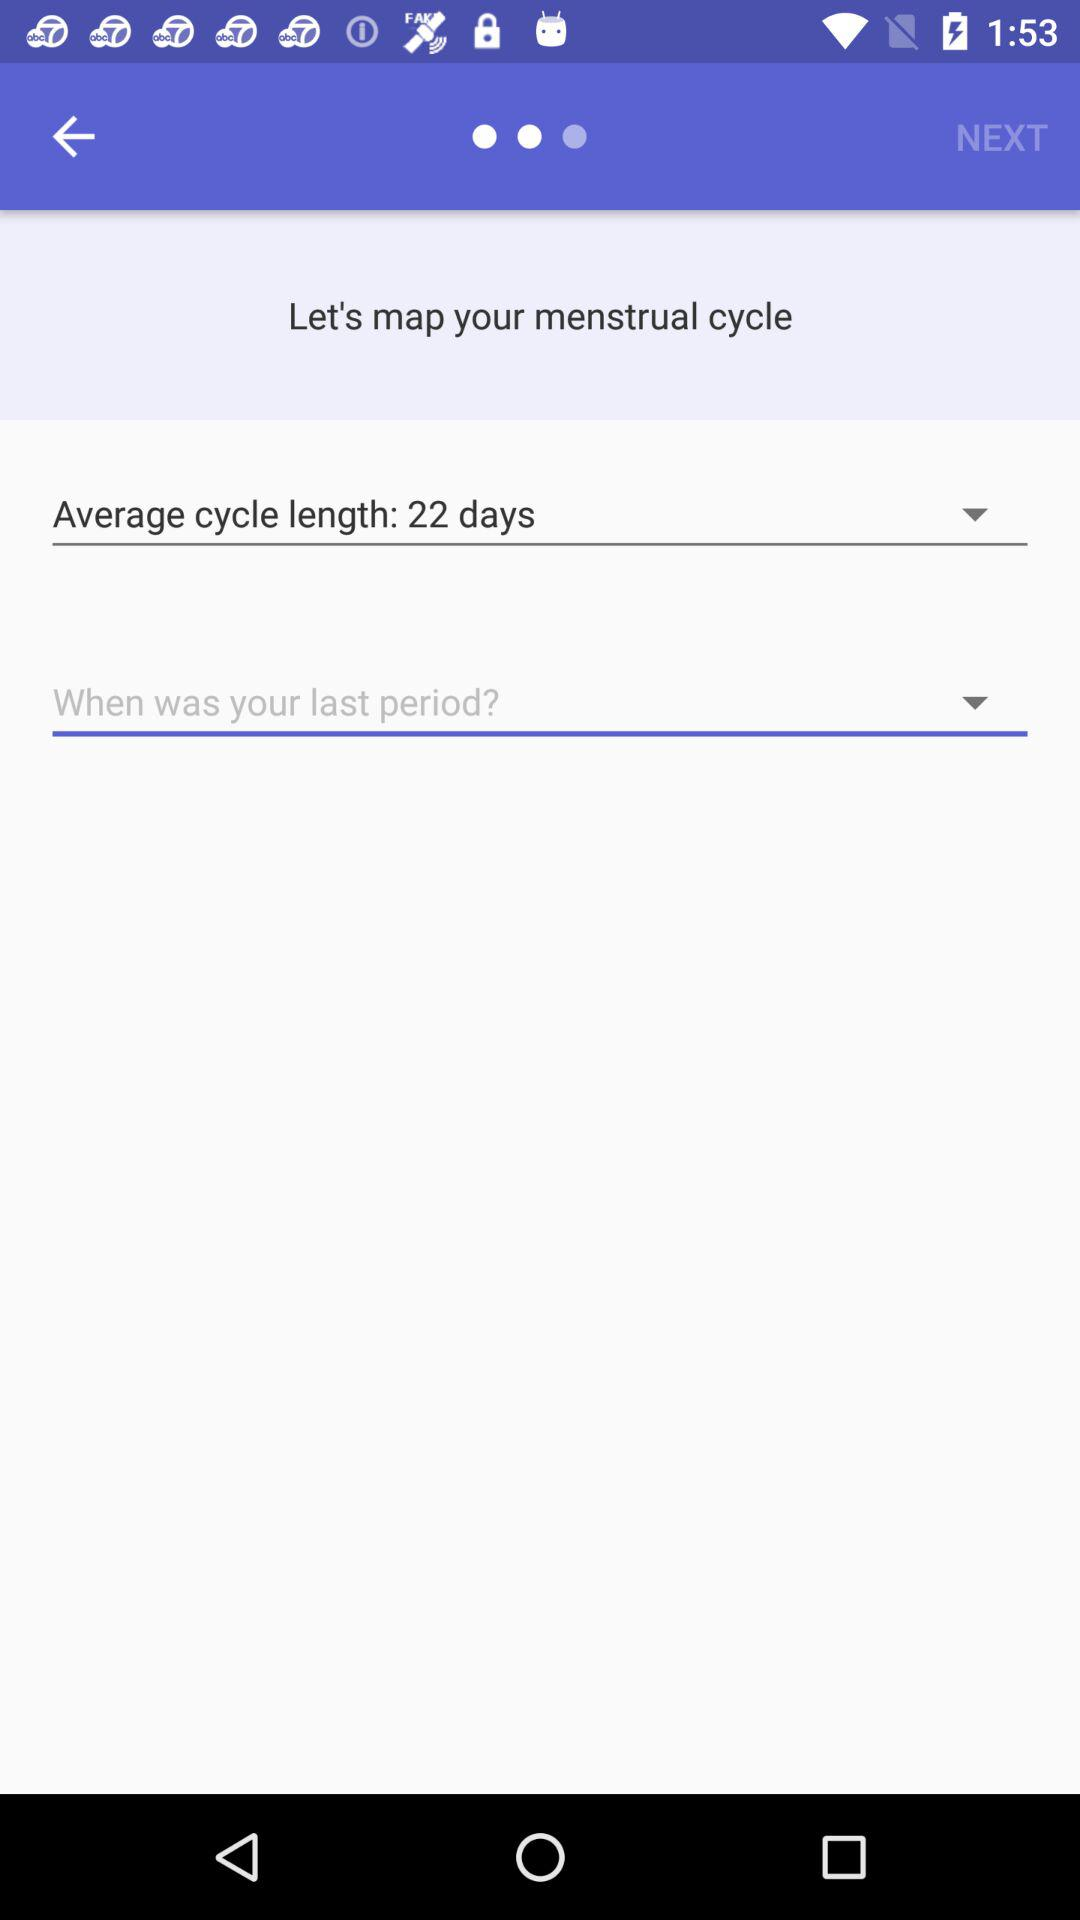How many days is the average cycle?
Answer the question using a single word or phrase. 22 days 